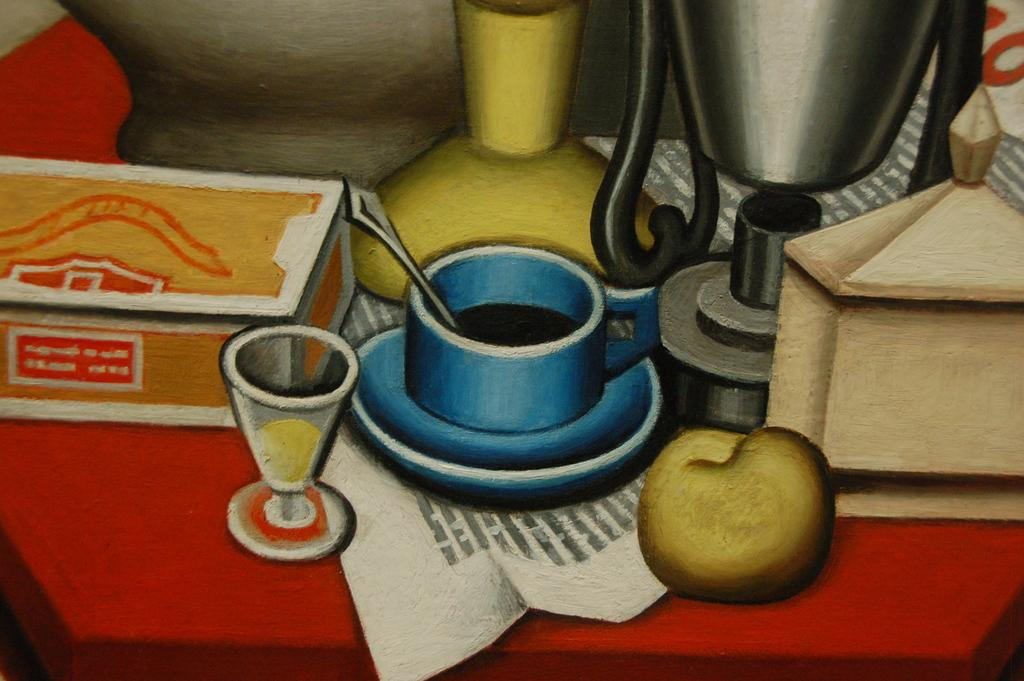What is depicted in the image? There is a drawing in the image. What is shown on the table in the drawing? The drawing contains a table with a fruit, a cup, a glass, and a box on it. Are there any other items on the table in the drawing? Yes, there are other items on the table in the drawing. Where is the pail located in the image? There is no pail present in the image. Can you tell me how many sinks are visible in the image? There are no sinks visible in the image. 